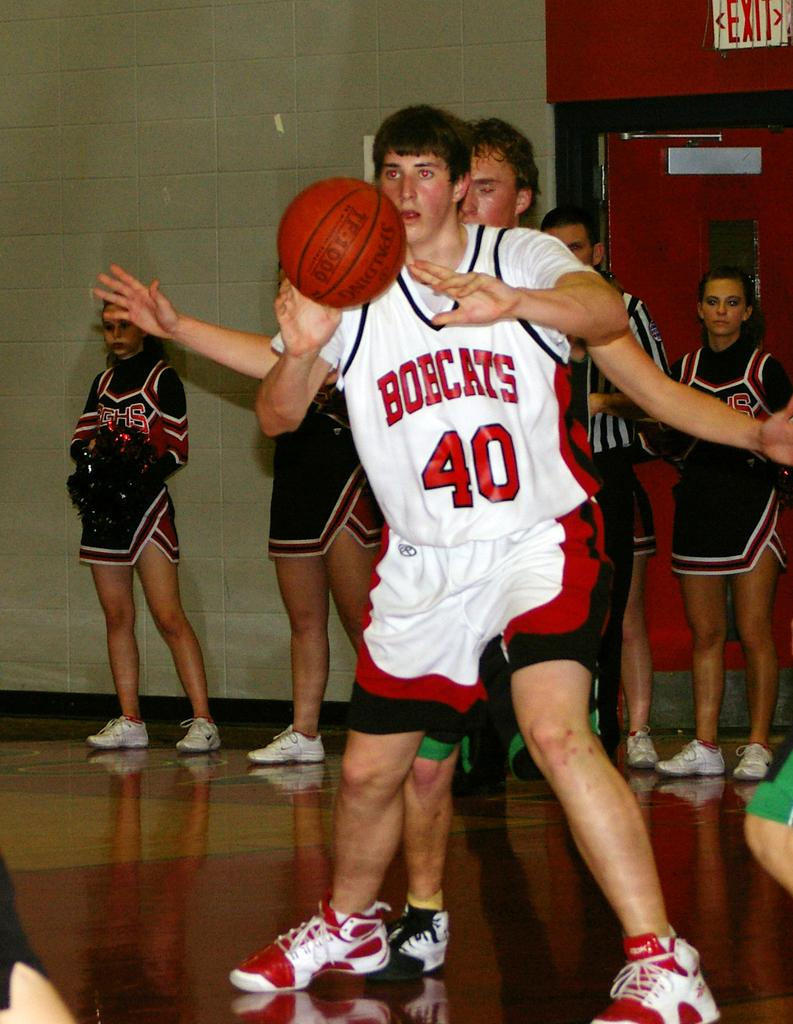<image>
Offer a succinct explanation of the picture presented. A number 40 Bobcat basketball player about to throw the ball in front of some cheerleaders. 